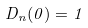<formula> <loc_0><loc_0><loc_500><loc_500>D _ { n } ( 0 ) = 1</formula> 